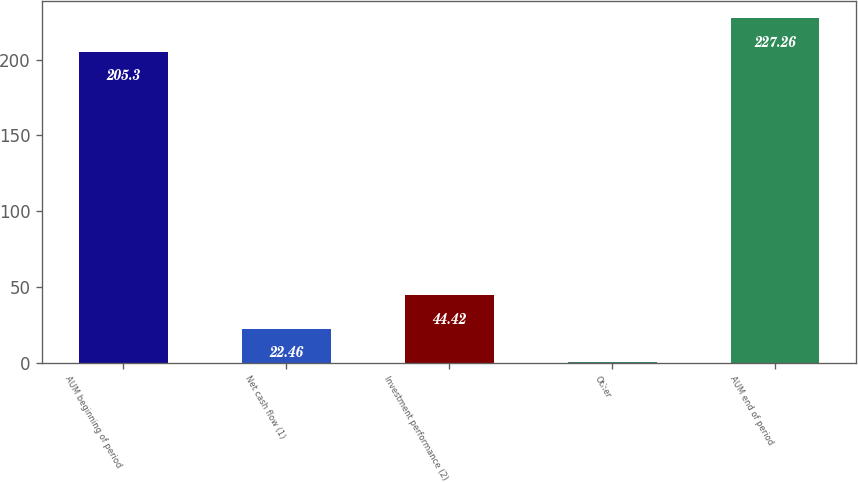<chart> <loc_0><loc_0><loc_500><loc_500><bar_chart><fcel>AUM beginning of period<fcel>Net cash flow (1)<fcel>Investment performance (2)<fcel>Other<fcel>AUM end of period<nl><fcel>205.3<fcel>22.46<fcel>44.42<fcel>0.5<fcel>227.26<nl></chart> 